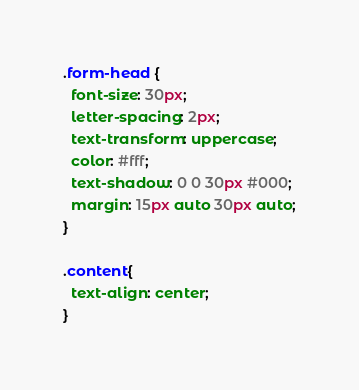Convert code to text. <code><loc_0><loc_0><loc_500><loc_500><_CSS_>.form-head {
  font-size: 30px;
  letter-spacing: 2px;
  text-transform: uppercase;
  color: #fff;
  text-shadow: 0 0 30px #000;
  margin: 15px auto 30px auto;
}

.content{
  text-align: center;
}
</code> 